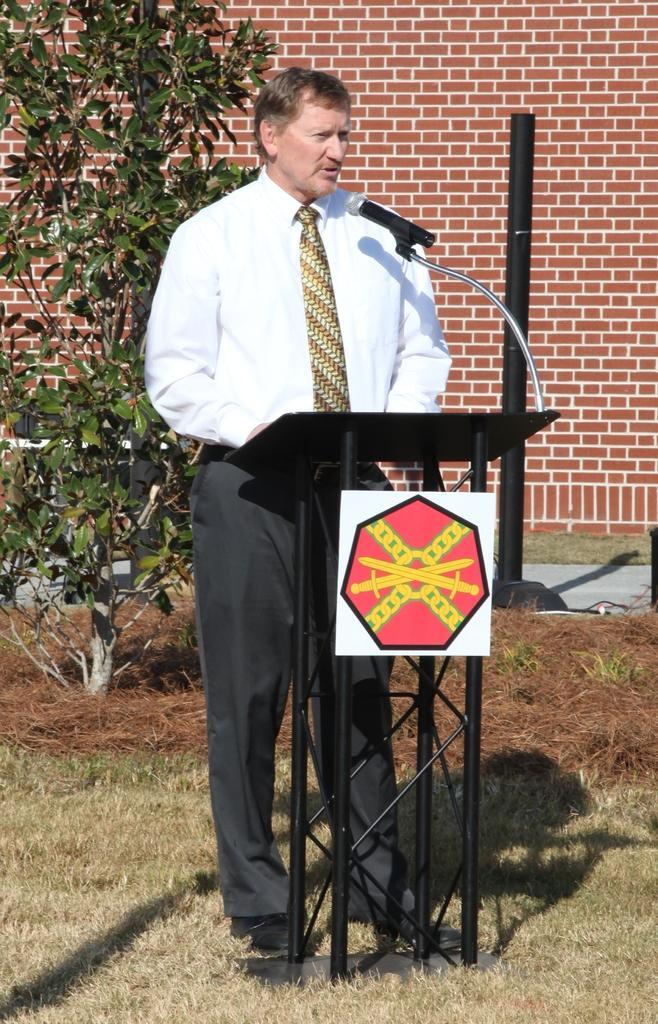Describe this image in one or two sentences. In this picture we can see the grass, podium with a board on it, pole, tree, path, man wore a tie and standing on the ground and in the background we can see the wall. 